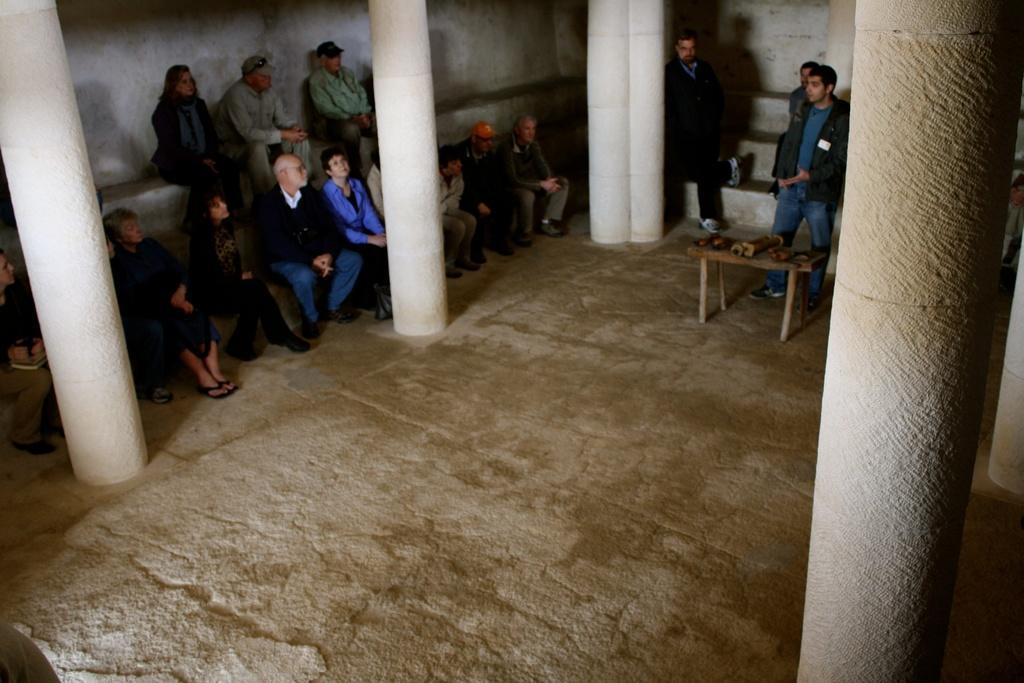Can you describe this image briefly? Here in this picture we can see many people are sitting on the steps. In the middle there is man standing. In front of him there is a table. On that table there are some items. To the middle corner there is a man standing. To the right corner there is a pole. To the left corner there is a pole. 